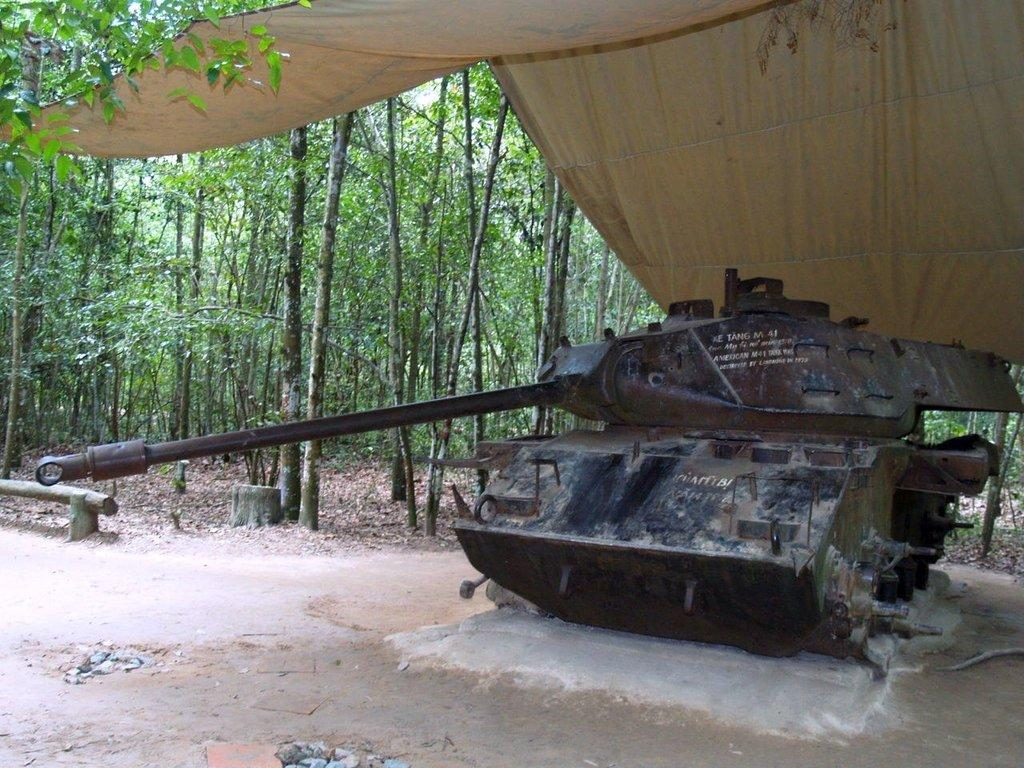What is the main subject of the image? The main subject of the image is a war tanker. Where is the war tanker located in the image? The war tanker is under a tent in the image. What can be seen in the background of the image? There are trees visible in the background of the image. What type of salt can be seen on the war tanker in the image? There is no salt present on the war tanker in the image. How many bananas are hanging from the trees in the background of the image? There are no bananas visible in the image; only trees are present in the background. 